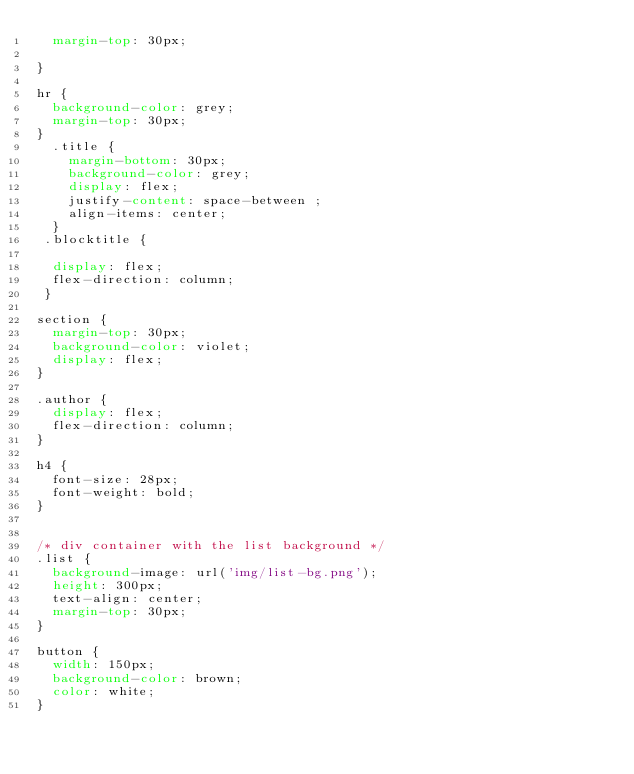<code> <loc_0><loc_0><loc_500><loc_500><_CSS_>  margin-top: 30px;
  
}

hr {
  background-color: grey;
  margin-top: 30px;
}
  .title {
    margin-bottom: 30px;
    background-color: grey;
    display: flex;
    justify-content: space-between ;
    align-items: center;
  }
 .blocktitle {

  display: flex;
  flex-direction: column;
 }

section { 
  margin-top: 30px;
  background-color: violet;
  display: flex;
}

.author {
  display: flex;
  flex-direction: column;
}

h4 {
  font-size: 28px;
  font-weight: bold;
}


/* div container with the list background */
.list {
  background-image: url('img/list-bg.png');
  height: 300px;
  text-align: center;
  margin-top: 30px;
}
 
button {
  width: 150px;
  background-color: brown;
  color: white;
}
</code> 